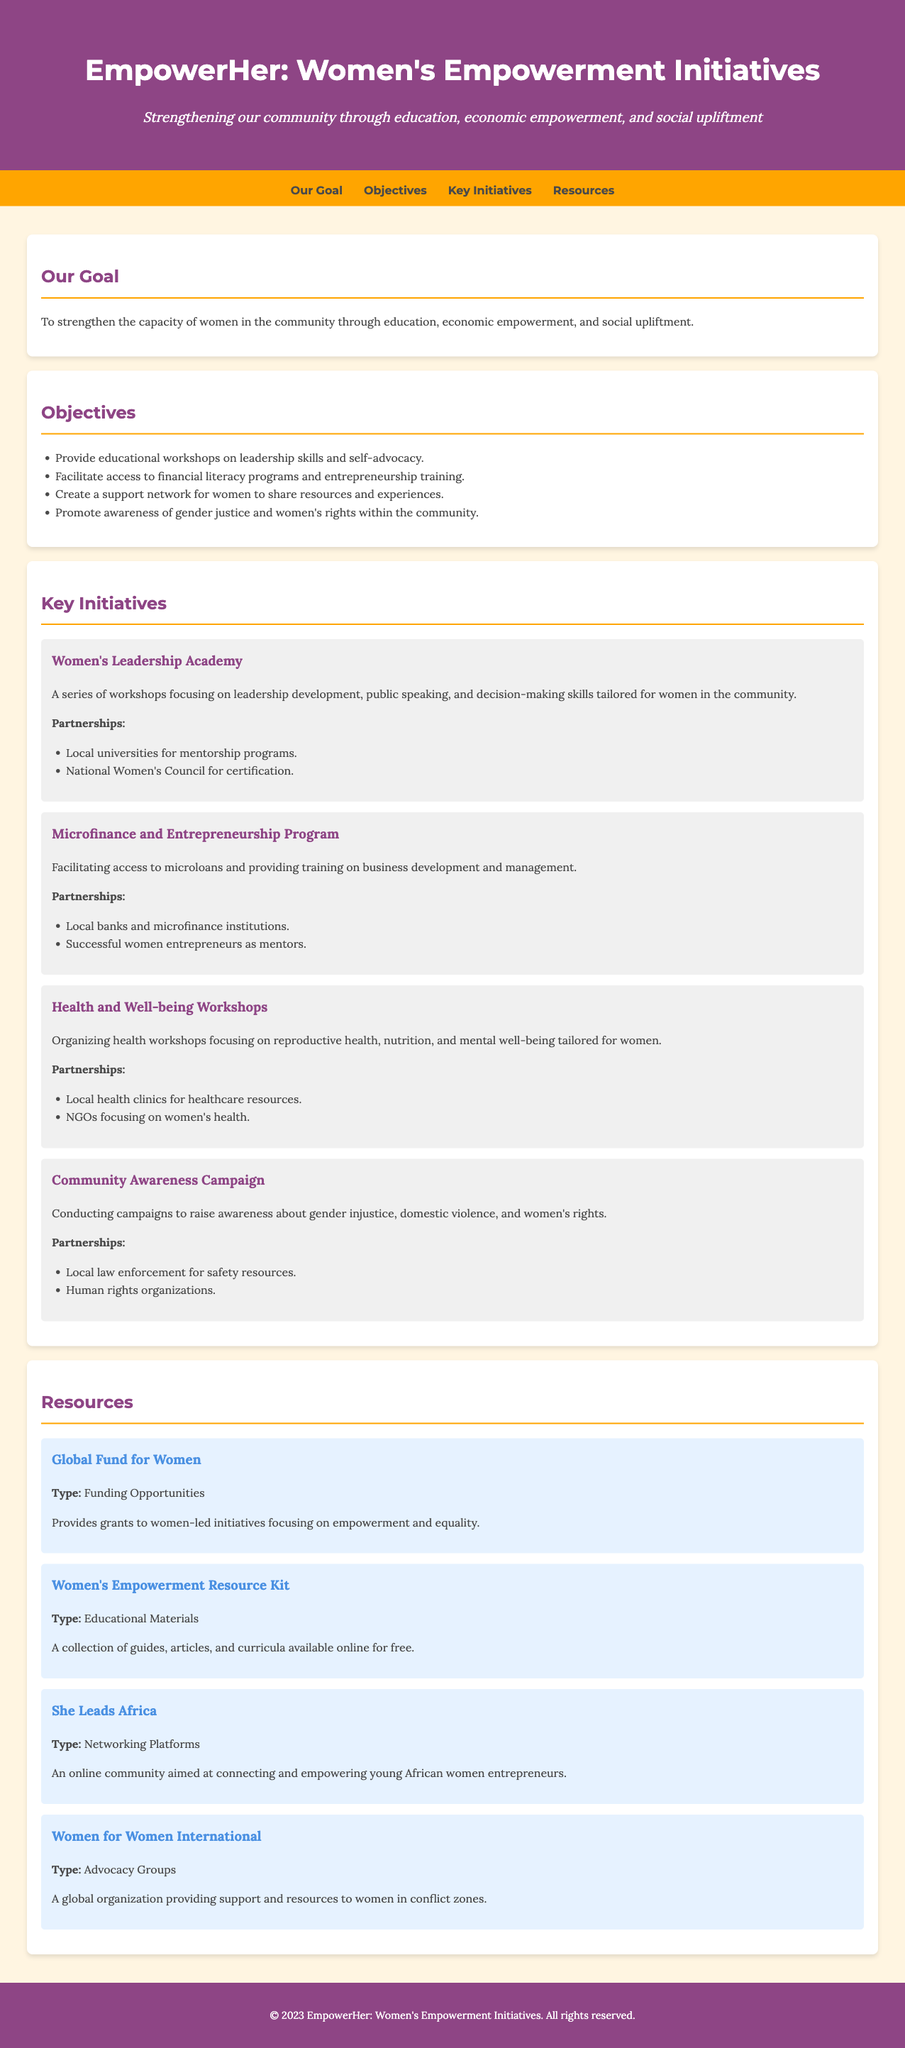What is the title of the program? The title of the program is found in the header section of the document.
Answer: EmpowerHer: Women's Empowerment Initiatives What is the main goal of the initiative? The main goal is specified in the "Our Goal" section of the document.
Answer: To strengthen the capacity of women in the community through education, economic empowerment, and social upliftment How many key initiatives are listed? The number of key initiatives can be counted in the "Key Initiatives" section.
Answer: Four What type of workshops does the Women's Leadership Academy focus on? The focus of the Women's Leadership Academy is mentioned in its description.
Answer: Leadership development Which partner organizations are included in the Microfinance and Entrepreneurship Program? The partner organizations can be found in the description of the Microfinance and Entrepreneurship Program.
Answer: Local banks and microfinance institutions What resource type is the "Global Fund for Women"? The type of resource is specified in the description of the resource.
Answer: Funding Opportunities What is the focus of the Health and Well-being Workshops? The focus area is described in the initiative section for Health and Well-being Workshops.
Answer: Reproductive health Who is the target demographic for She Leads Africa? The target demographic is identified in the description of the platform.
Answer: Young African women entrepreneurs What is the main purpose of the Community Awareness Campaign? The main purpose is clearly stated in the initiative's description.
Answer: Raise awareness about gender injustice 